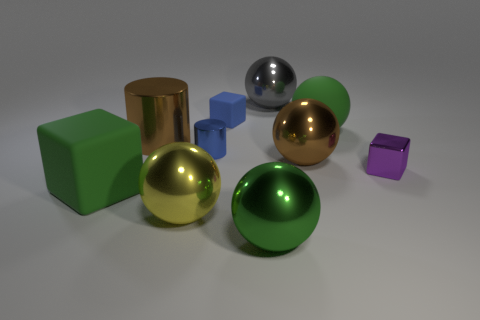The metallic sphere that is the same color as the large matte cube is what size?
Make the answer very short. Large. What color is the big matte block?
Ensure brevity in your answer.  Green. There is a brown thing right of the yellow sphere; does it have the same shape as the big gray object?
Your answer should be compact. Yes. There is a rubber thing in front of the tiny metal object that is in front of the brown object in front of the blue cylinder; what is its shape?
Provide a short and direct response. Cube. What is the green sphere behind the big green shiny ball made of?
Ensure brevity in your answer.  Rubber. The rubber cube that is the same size as the blue metallic object is what color?
Keep it short and to the point. Blue. What number of other objects are the same shape as the green metallic object?
Your response must be concise. 4. Do the green shiny thing and the gray sphere have the same size?
Your answer should be very brief. Yes. Is the number of metallic spheres in front of the blue rubber block greater than the number of large things that are right of the green rubber block?
Your answer should be very brief. No. What number of other things are there of the same size as the matte ball?
Give a very brief answer. 6. 